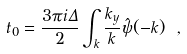Convert formula to latex. <formula><loc_0><loc_0><loc_500><loc_500>t _ { 0 } = \frac { 3 \pi i \Delta } { 2 } \int _ { k } \frac { k _ { y } } { k } \hat { \psi } ( - { k } ) \ ,</formula> 